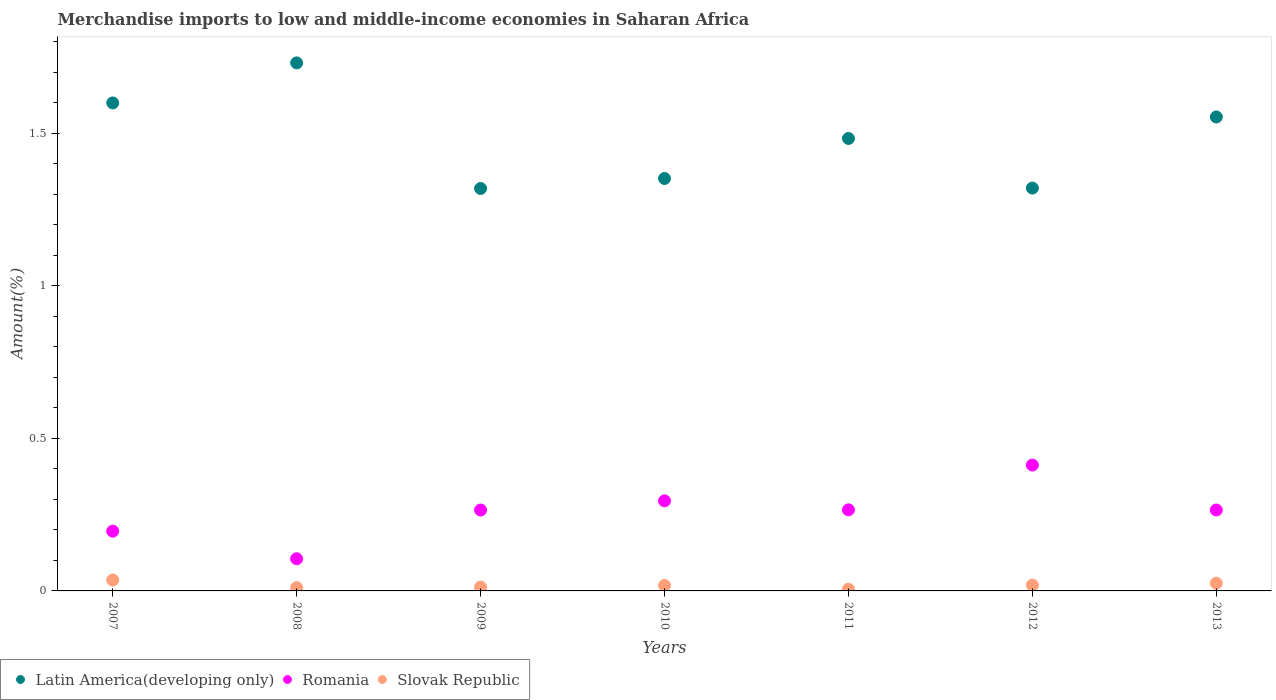How many different coloured dotlines are there?
Offer a very short reply. 3. What is the percentage of amount earned from merchandise imports in Slovak Republic in 2011?
Provide a succinct answer. 0.01. Across all years, what is the maximum percentage of amount earned from merchandise imports in Romania?
Give a very brief answer. 0.41. Across all years, what is the minimum percentage of amount earned from merchandise imports in Latin America(developing only)?
Offer a terse response. 1.32. In which year was the percentage of amount earned from merchandise imports in Latin America(developing only) minimum?
Your response must be concise. 2009. What is the total percentage of amount earned from merchandise imports in Romania in the graph?
Your answer should be compact. 1.81. What is the difference between the percentage of amount earned from merchandise imports in Romania in 2011 and that in 2013?
Provide a short and direct response. 0. What is the difference between the percentage of amount earned from merchandise imports in Latin America(developing only) in 2007 and the percentage of amount earned from merchandise imports in Slovak Republic in 2012?
Ensure brevity in your answer.  1.58. What is the average percentage of amount earned from merchandise imports in Latin America(developing only) per year?
Keep it short and to the point. 1.48. In the year 2013, what is the difference between the percentage of amount earned from merchandise imports in Romania and percentage of amount earned from merchandise imports in Latin America(developing only)?
Your answer should be compact. -1.29. In how many years, is the percentage of amount earned from merchandise imports in Slovak Republic greater than 1 %?
Keep it short and to the point. 0. What is the ratio of the percentage of amount earned from merchandise imports in Slovak Republic in 2011 to that in 2013?
Offer a terse response. 0.23. Is the difference between the percentage of amount earned from merchandise imports in Romania in 2008 and 2013 greater than the difference between the percentage of amount earned from merchandise imports in Latin America(developing only) in 2008 and 2013?
Give a very brief answer. No. What is the difference between the highest and the second highest percentage of amount earned from merchandise imports in Romania?
Provide a short and direct response. 0.12. What is the difference between the highest and the lowest percentage of amount earned from merchandise imports in Slovak Republic?
Ensure brevity in your answer.  0.03. In how many years, is the percentage of amount earned from merchandise imports in Romania greater than the average percentage of amount earned from merchandise imports in Romania taken over all years?
Ensure brevity in your answer.  5. Is the sum of the percentage of amount earned from merchandise imports in Latin America(developing only) in 2010 and 2012 greater than the maximum percentage of amount earned from merchandise imports in Romania across all years?
Make the answer very short. Yes. How many years are there in the graph?
Make the answer very short. 7. What is the difference between two consecutive major ticks on the Y-axis?
Make the answer very short. 0.5. Where does the legend appear in the graph?
Your answer should be very brief. Bottom left. How many legend labels are there?
Your response must be concise. 3. What is the title of the graph?
Ensure brevity in your answer.  Merchandise imports to low and middle-income economies in Saharan Africa. What is the label or title of the X-axis?
Offer a very short reply. Years. What is the label or title of the Y-axis?
Provide a succinct answer. Amount(%). What is the Amount(%) of Latin America(developing only) in 2007?
Offer a very short reply. 1.6. What is the Amount(%) of Romania in 2007?
Keep it short and to the point. 0.2. What is the Amount(%) of Slovak Republic in 2007?
Ensure brevity in your answer.  0.04. What is the Amount(%) of Latin America(developing only) in 2008?
Give a very brief answer. 1.73. What is the Amount(%) of Romania in 2008?
Provide a short and direct response. 0.11. What is the Amount(%) of Slovak Republic in 2008?
Make the answer very short. 0.01. What is the Amount(%) of Latin America(developing only) in 2009?
Provide a succinct answer. 1.32. What is the Amount(%) of Romania in 2009?
Provide a short and direct response. 0.27. What is the Amount(%) of Slovak Republic in 2009?
Keep it short and to the point. 0.01. What is the Amount(%) of Latin America(developing only) in 2010?
Offer a terse response. 1.35. What is the Amount(%) in Romania in 2010?
Your answer should be compact. 0.3. What is the Amount(%) in Slovak Republic in 2010?
Give a very brief answer. 0.02. What is the Amount(%) of Latin America(developing only) in 2011?
Provide a short and direct response. 1.48. What is the Amount(%) in Romania in 2011?
Your answer should be very brief. 0.27. What is the Amount(%) in Slovak Republic in 2011?
Provide a short and direct response. 0.01. What is the Amount(%) of Latin America(developing only) in 2012?
Keep it short and to the point. 1.32. What is the Amount(%) of Romania in 2012?
Your answer should be very brief. 0.41. What is the Amount(%) of Slovak Republic in 2012?
Ensure brevity in your answer.  0.02. What is the Amount(%) in Latin America(developing only) in 2013?
Offer a terse response. 1.55. What is the Amount(%) of Romania in 2013?
Keep it short and to the point. 0.27. What is the Amount(%) of Slovak Republic in 2013?
Give a very brief answer. 0.03. Across all years, what is the maximum Amount(%) in Latin America(developing only)?
Keep it short and to the point. 1.73. Across all years, what is the maximum Amount(%) of Romania?
Your answer should be compact. 0.41. Across all years, what is the maximum Amount(%) in Slovak Republic?
Your answer should be compact. 0.04. Across all years, what is the minimum Amount(%) of Latin America(developing only)?
Give a very brief answer. 1.32. Across all years, what is the minimum Amount(%) of Romania?
Your response must be concise. 0.11. Across all years, what is the minimum Amount(%) of Slovak Republic?
Provide a succinct answer. 0.01. What is the total Amount(%) in Latin America(developing only) in the graph?
Your answer should be compact. 10.36. What is the total Amount(%) of Romania in the graph?
Offer a terse response. 1.81. What is the total Amount(%) of Slovak Republic in the graph?
Your answer should be compact. 0.13. What is the difference between the Amount(%) of Latin America(developing only) in 2007 and that in 2008?
Keep it short and to the point. -0.13. What is the difference between the Amount(%) of Romania in 2007 and that in 2008?
Keep it short and to the point. 0.09. What is the difference between the Amount(%) of Slovak Republic in 2007 and that in 2008?
Offer a terse response. 0.02. What is the difference between the Amount(%) in Latin America(developing only) in 2007 and that in 2009?
Your answer should be compact. 0.28. What is the difference between the Amount(%) of Romania in 2007 and that in 2009?
Ensure brevity in your answer.  -0.07. What is the difference between the Amount(%) of Slovak Republic in 2007 and that in 2009?
Your response must be concise. 0.02. What is the difference between the Amount(%) of Latin America(developing only) in 2007 and that in 2010?
Your response must be concise. 0.25. What is the difference between the Amount(%) in Romania in 2007 and that in 2010?
Provide a succinct answer. -0.1. What is the difference between the Amount(%) of Slovak Republic in 2007 and that in 2010?
Your answer should be compact. 0.02. What is the difference between the Amount(%) of Latin America(developing only) in 2007 and that in 2011?
Ensure brevity in your answer.  0.12. What is the difference between the Amount(%) of Romania in 2007 and that in 2011?
Provide a short and direct response. -0.07. What is the difference between the Amount(%) in Slovak Republic in 2007 and that in 2011?
Your answer should be very brief. 0.03. What is the difference between the Amount(%) in Latin America(developing only) in 2007 and that in 2012?
Your answer should be compact. 0.28. What is the difference between the Amount(%) in Romania in 2007 and that in 2012?
Your response must be concise. -0.22. What is the difference between the Amount(%) in Slovak Republic in 2007 and that in 2012?
Ensure brevity in your answer.  0.02. What is the difference between the Amount(%) of Latin America(developing only) in 2007 and that in 2013?
Offer a very short reply. 0.05. What is the difference between the Amount(%) in Romania in 2007 and that in 2013?
Ensure brevity in your answer.  -0.07. What is the difference between the Amount(%) of Slovak Republic in 2007 and that in 2013?
Provide a short and direct response. 0.01. What is the difference between the Amount(%) in Latin America(developing only) in 2008 and that in 2009?
Your answer should be compact. 0.41. What is the difference between the Amount(%) of Romania in 2008 and that in 2009?
Ensure brevity in your answer.  -0.16. What is the difference between the Amount(%) of Slovak Republic in 2008 and that in 2009?
Give a very brief answer. -0. What is the difference between the Amount(%) of Latin America(developing only) in 2008 and that in 2010?
Your answer should be compact. 0.38. What is the difference between the Amount(%) in Romania in 2008 and that in 2010?
Keep it short and to the point. -0.19. What is the difference between the Amount(%) of Slovak Republic in 2008 and that in 2010?
Your response must be concise. -0.01. What is the difference between the Amount(%) in Latin America(developing only) in 2008 and that in 2011?
Your response must be concise. 0.25. What is the difference between the Amount(%) of Romania in 2008 and that in 2011?
Your response must be concise. -0.16. What is the difference between the Amount(%) in Slovak Republic in 2008 and that in 2011?
Offer a very short reply. 0.01. What is the difference between the Amount(%) of Latin America(developing only) in 2008 and that in 2012?
Provide a short and direct response. 0.41. What is the difference between the Amount(%) of Romania in 2008 and that in 2012?
Your answer should be compact. -0.31. What is the difference between the Amount(%) in Slovak Republic in 2008 and that in 2012?
Provide a short and direct response. -0.01. What is the difference between the Amount(%) of Latin America(developing only) in 2008 and that in 2013?
Your answer should be very brief. 0.18. What is the difference between the Amount(%) of Romania in 2008 and that in 2013?
Your answer should be very brief. -0.16. What is the difference between the Amount(%) of Slovak Republic in 2008 and that in 2013?
Your answer should be very brief. -0.01. What is the difference between the Amount(%) in Latin America(developing only) in 2009 and that in 2010?
Offer a terse response. -0.03. What is the difference between the Amount(%) in Romania in 2009 and that in 2010?
Your answer should be very brief. -0.03. What is the difference between the Amount(%) in Slovak Republic in 2009 and that in 2010?
Make the answer very short. -0.01. What is the difference between the Amount(%) in Latin America(developing only) in 2009 and that in 2011?
Provide a succinct answer. -0.16. What is the difference between the Amount(%) in Romania in 2009 and that in 2011?
Your answer should be very brief. -0. What is the difference between the Amount(%) of Slovak Republic in 2009 and that in 2011?
Keep it short and to the point. 0.01. What is the difference between the Amount(%) in Latin America(developing only) in 2009 and that in 2012?
Provide a short and direct response. -0. What is the difference between the Amount(%) in Romania in 2009 and that in 2012?
Make the answer very short. -0.15. What is the difference between the Amount(%) of Slovak Republic in 2009 and that in 2012?
Ensure brevity in your answer.  -0.01. What is the difference between the Amount(%) in Latin America(developing only) in 2009 and that in 2013?
Ensure brevity in your answer.  -0.23. What is the difference between the Amount(%) in Romania in 2009 and that in 2013?
Your answer should be very brief. -0. What is the difference between the Amount(%) of Slovak Republic in 2009 and that in 2013?
Give a very brief answer. -0.01. What is the difference between the Amount(%) in Latin America(developing only) in 2010 and that in 2011?
Provide a succinct answer. -0.13. What is the difference between the Amount(%) in Romania in 2010 and that in 2011?
Your answer should be compact. 0.03. What is the difference between the Amount(%) in Slovak Republic in 2010 and that in 2011?
Keep it short and to the point. 0.01. What is the difference between the Amount(%) in Latin America(developing only) in 2010 and that in 2012?
Provide a succinct answer. 0.03. What is the difference between the Amount(%) in Romania in 2010 and that in 2012?
Your response must be concise. -0.12. What is the difference between the Amount(%) of Slovak Republic in 2010 and that in 2012?
Make the answer very short. -0. What is the difference between the Amount(%) of Latin America(developing only) in 2010 and that in 2013?
Provide a short and direct response. -0.2. What is the difference between the Amount(%) of Romania in 2010 and that in 2013?
Your answer should be very brief. 0.03. What is the difference between the Amount(%) of Slovak Republic in 2010 and that in 2013?
Make the answer very short. -0.01. What is the difference between the Amount(%) in Latin America(developing only) in 2011 and that in 2012?
Keep it short and to the point. 0.16. What is the difference between the Amount(%) of Romania in 2011 and that in 2012?
Offer a very short reply. -0.15. What is the difference between the Amount(%) of Slovak Republic in 2011 and that in 2012?
Offer a very short reply. -0.01. What is the difference between the Amount(%) of Latin America(developing only) in 2011 and that in 2013?
Keep it short and to the point. -0.07. What is the difference between the Amount(%) of Slovak Republic in 2011 and that in 2013?
Your answer should be very brief. -0.02. What is the difference between the Amount(%) of Latin America(developing only) in 2012 and that in 2013?
Make the answer very short. -0.23. What is the difference between the Amount(%) in Romania in 2012 and that in 2013?
Your response must be concise. 0.15. What is the difference between the Amount(%) of Slovak Republic in 2012 and that in 2013?
Give a very brief answer. -0.01. What is the difference between the Amount(%) in Latin America(developing only) in 2007 and the Amount(%) in Romania in 2008?
Keep it short and to the point. 1.49. What is the difference between the Amount(%) of Latin America(developing only) in 2007 and the Amount(%) of Slovak Republic in 2008?
Keep it short and to the point. 1.59. What is the difference between the Amount(%) of Romania in 2007 and the Amount(%) of Slovak Republic in 2008?
Give a very brief answer. 0.19. What is the difference between the Amount(%) in Latin America(developing only) in 2007 and the Amount(%) in Romania in 2009?
Ensure brevity in your answer.  1.33. What is the difference between the Amount(%) of Latin America(developing only) in 2007 and the Amount(%) of Slovak Republic in 2009?
Ensure brevity in your answer.  1.59. What is the difference between the Amount(%) of Romania in 2007 and the Amount(%) of Slovak Republic in 2009?
Your response must be concise. 0.18. What is the difference between the Amount(%) of Latin America(developing only) in 2007 and the Amount(%) of Romania in 2010?
Offer a terse response. 1.3. What is the difference between the Amount(%) in Latin America(developing only) in 2007 and the Amount(%) in Slovak Republic in 2010?
Provide a succinct answer. 1.58. What is the difference between the Amount(%) in Romania in 2007 and the Amount(%) in Slovak Republic in 2010?
Offer a very short reply. 0.18. What is the difference between the Amount(%) in Latin America(developing only) in 2007 and the Amount(%) in Romania in 2011?
Your answer should be very brief. 1.33. What is the difference between the Amount(%) in Latin America(developing only) in 2007 and the Amount(%) in Slovak Republic in 2011?
Ensure brevity in your answer.  1.59. What is the difference between the Amount(%) in Romania in 2007 and the Amount(%) in Slovak Republic in 2011?
Provide a short and direct response. 0.19. What is the difference between the Amount(%) in Latin America(developing only) in 2007 and the Amount(%) in Romania in 2012?
Provide a succinct answer. 1.19. What is the difference between the Amount(%) in Latin America(developing only) in 2007 and the Amount(%) in Slovak Republic in 2012?
Give a very brief answer. 1.58. What is the difference between the Amount(%) in Romania in 2007 and the Amount(%) in Slovak Republic in 2012?
Keep it short and to the point. 0.18. What is the difference between the Amount(%) in Latin America(developing only) in 2007 and the Amount(%) in Romania in 2013?
Keep it short and to the point. 1.33. What is the difference between the Amount(%) of Latin America(developing only) in 2007 and the Amount(%) of Slovak Republic in 2013?
Keep it short and to the point. 1.57. What is the difference between the Amount(%) in Romania in 2007 and the Amount(%) in Slovak Republic in 2013?
Provide a short and direct response. 0.17. What is the difference between the Amount(%) of Latin America(developing only) in 2008 and the Amount(%) of Romania in 2009?
Keep it short and to the point. 1.47. What is the difference between the Amount(%) in Latin America(developing only) in 2008 and the Amount(%) in Slovak Republic in 2009?
Your response must be concise. 1.72. What is the difference between the Amount(%) in Romania in 2008 and the Amount(%) in Slovak Republic in 2009?
Your response must be concise. 0.09. What is the difference between the Amount(%) in Latin America(developing only) in 2008 and the Amount(%) in Romania in 2010?
Your answer should be compact. 1.44. What is the difference between the Amount(%) in Latin America(developing only) in 2008 and the Amount(%) in Slovak Republic in 2010?
Make the answer very short. 1.71. What is the difference between the Amount(%) in Romania in 2008 and the Amount(%) in Slovak Republic in 2010?
Give a very brief answer. 0.09. What is the difference between the Amount(%) of Latin America(developing only) in 2008 and the Amount(%) of Romania in 2011?
Your answer should be very brief. 1.47. What is the difference between the Amount(%) of Latin America(developing only) in 2008 and the Amount(%) of Slovak Republic in 2011?
Offer a terse response. 1.73. What is the difference between the Amount(%) of Romania in 2008 and the Amount(%) of Slovak Republic in 2011?
Give a very brief answer. 0.1. What is the difference between the Amount(%) of Latin America(developing only) in 2008 and the Amount(%) of Romania in 2012?
Give a very brief answer. 1.32. What is the difference between the Amount(%) of Latin America(developing only) in 2008 and the Amount(%) of Slovak Republic in 2012?
Offer a very short reply. 1.71. What is the difference between the Amount(%) of Romania in 2008 and the Amount(%) of Slovak Republic in 2012?
Provide a short and direct response. 0.09. What is the difference between the Amount(%) in Latin America(developing only) in 2008 and the Amount(%) in Romania in 2013?
Your answer should be compact. 1.47. What is the difference between the Amount(%) of Latin America(developing only) in 2008 and the Amount(%) of Slovak Republic in 2013?
Keep it short and to the point. 1.71. What is the difference between the Amount(%) in Romania in 2008 and the Amount(%) in Slovak Republic in 2013?
Make the answer very short. 0.08. What is the difference between the Amount(%) of Latin America(developing only) in 2009 and the Amount(%) of Romania in 2010?
Provide a succinct answer. 1.02. What is the difference between the Amount(%) in Latin America(developing only) in 2009 and the Amount(%) in Slovak Republic in 2010?
Ensure brevity in your answer.  1.3. What is the difference between the Amount(%) of Romania in 2009 and the Amount(%) of Slovak Republic in 2010?
Make the answer very short. 0.25. What is the difference between the Amount(%) in Latin America(developing only) in 2009 and the Amount(%) in Romania in 2011?
Offer a terse response. 1.05. What is the difference between the Amount(%) of Latin America(developing only) in 2009 and the Amount(%) of Slovak Republic in 2011?
Provide a short and direct response. 1.31. What is the difference between the Amount(%) in Romania in 2009 and the Amount(%) in Slovak Republic in 2011?
Your answer should be very brief. 0.26. What is the difference between the Amount(%) of Latin America(developing only) in 2009 and the Amount(%) of Romania in 2012?
Your answer should be compact. 0.91. What is the difference between the Amount(%) in Latin America(developing only) in 2009 and the Amount(%) in Slovak Republic in 2012?
Give a very brief answer. 1.3. What is the difference between the Amount(%) of Romania in 2009 and the Amount(%) of Slovak Republic in 2012?
Offer a very short reply. 0.25. What is the difference between the Amount(%) in Latin America(developing only) in 2009 and the Amount(%) in Romania in 2013?
Offer a terse response. 1.05. What is the difference between the Amount(%) in Latin America(developing only) in 2009 and the Amount(%) in Slovak Republic in 2013?
Ensure brevity in your answer.  1.29. What is the difference between the Amount(%) in Romania in 2009 and the Amount(%) in Slovak Republic in 2013?
Your answer should be compact. 0.24. What is the difference between the Amount(%) in Latin America(developing only) in 2010 and the Amount(%) in Romania in 2011?
Offer a terse response. 1.09. What is the difference between the Amount(%) of Latin America(developing only) in 2010 and the Amount(%) of Slovak Republic in 2011?
Make the answer very short. 1.35. What is the difference between the Amount(%) of Romania in 2010 and the Amount(%) of Slovak Republic in 2011?
Provide a succinct answer. 0.29. What is the difference between the Amount(%) in Latin America(developing only) in 2010 and the Amount(%) in Romania in 2012?
Offer a terse response. 0.94. What is the difference between the Amount(%) in Latin America(developing only) in 2010 and the Amount(%) in Slovak Republic in 2012?
Your response must be concise. 1.33. What is the difference between the Amount(%) in Romania in 2010 and the Amount(%) in Slovak Republic in 2012?
Give a very brief answer. 0.28. What is the difference between the Amount(%) in Latin America(developing only) in 2010 and the Amount(%) in Romania in 2013?
Give a very brief answer. 1.09. What is the difference between the Amount(%) in Latin America(developing only) in 2010 and the Amount(%) in Slovak Republic in 2013?
Keep it short and to the point. 1.33. What is the difference between the Amount(%) in Romania in 2010 and the Amount(%) in Slovak Republic in 2013?
Provide a succinct answer. 0.27. What is the difference between the Amount(%) of Latin America(developing only) in 2011 and the Amount(%) of Romania in 2012?
Keep it short and to the point. 1.07. What is the difference between the Amount(%) in Latin America(developing only) in 2011 and the Amount(%) in Slovak Republic in 2012?
Keep it short and to the point. 1.46. What is the difference between the Amount(%) in Romania in 2011 and the Amount(%) in Slovak Republic in 2012?
Give a very brief answer. 0.25. What is the difference between the Amount(%) of Latin America(developing only) in 2011 and the Amount(%) of Romania in 2013?
Make the answer very short. 1.22. What is the difference between the Amount(%) in Latin America(developing only) in 2011 and the Amount(%) in Slovak Republic in 2013?
Your response must be concise. 1.46. What is the difference between the Amount(%) in Romania in 2011 and the Amount(%) in Slovak Republic in 2013?
Provide a short and direct response. 0.24. What is the difference between the Amount(%) in Latin America(developing only) in 2012 and the Amount(%) in Romania in 2013?
Your answer should be very brief. 1.06. What is the difference between the Amount(%) in Latin America(developing only) in 2012 and the Amount(%) in Slovak Republic in 2013?
Offer a terse response. 1.3. What is the difference between the Amount(%) of Romania in 2012 and the Amount(%) of Slovak Republic in 2013?
Your answer should be compact. 0.39. What is the average Amount(%) in Latin America(developing only) per year?
Your answer should be very brief. 1.48. What is the average Amount(%) in Romania per year?
Ensure brevity in your answer.  0.26. What is the average Amount(%) of Slovak Republic per year?
Your response must be concise. 0.02. In the year 2007, what is the difference between the Amount(%) in Latin America(developing only) and Amount(%) in Romania?
Your response must be concise. 1.4. In the year 2007, what is the difference between the Amount(%) in Latin America(developing only) and Amount(%) in Slovak Republic?
Offer a terse response. 1.56. In the year 2007, what is the difference between the Amount(%) of Romania and Amount(%) of Slovak Republic?
Offer a very short reply. 0.16. In the year 2008, what is the difference between the Amount(%) of Latin America(developing only) and Amount(%) of Romania?
Offer a very short reply. 1.63. In the year 2008, what is the difference between the Amount(%) of Latin America(developing only) and Amount(%) of Slovak Republic?
Keep it short and to the point. 1.72. In the year 2008, what is the difference between the Amount(%) in Romania and Amount(%) in Slovak Republic?
Your answer should be compact. 0.09. In the year 2009, what is the difference between the Amount(%) in Latin America(developing only) and Amount(%) in Romania?
Ensure brevity in your answer.  1.05. In the year 2009, what is the difference between the Amount(%) of Latin America(developing only) and Amount(%) of Slovak Republic?
Offer a terse response. 1.31. In the year 2009, what is the difference between the Amount(%) of Romania and Amount(%) of Slovak Republic?
Provide a succinct answer. 0.25. In the year 2010, what is the difference between the Amount(%) of Latin America(developing only) and Amount(%) of Romania?
Offer a terse response. 1.06. In the year 2010, what is the difference between the Amount(%) in Latin America(developing only) and Amount(%) in Slovak Republic?
Ensure brevity in your answer.  1.33. In the year 2010, what is the difference between the Amount(%) of Romania and Amount(%) of Slovak Republic?
Keep it short and to the point. 0.28. In the year 2011, what is the difference between the Amount(%) in Latin America(developing only) and Amount(%) in Romania?
Ensure brevity in your answer.  1.22. In the year 2011, what is the difference between the Amount(%) in Latin America(developing only) and Amount(%) in Slovak Republic?
Give a very brief answer. 1.48. In the year 2011, what is the difference between the Amount(%) of Romania and Amount(%) of Slovak Republic?
Ensure brevity in your answer.  0.26. In the year 2012, what is the difference between the Amount(%) of Latin America(developing only) and Amount(%) of Romania?
Your answer should be compact. 0.91. In the year 2012, what is the difference between the Amount(%) of Latin America(developing only) and Amount(%) of Slovak Republic?
Your answer should be compact. 1.3. In the year 2012, what is the difference between the Amount(%) in Romania and Amount(%) in Slovak Republic?
Ensure brevity in your answer.  0.39. In the year 2013, what is the difference between the Amount(%) of Latin America(developing only) and Amount(%) of Romania?
Keep it short and to the point. 1.29. In the year 2013, what is the difference between the Amount(%) in Latin America(developing only) and Amount(%) in Slovak Republic?
Provide a short and direct response. 1.53. In the year 2013, what is the difference between the Amount(%) of Romania and Amount(%) of Slovak Republic?
Offer a very short reply. 0.24. What is the ratio of the Amount(%) of Latin America(developing only) in 2007 to that in 2008?
Make the answer very short. 0.92. What is the ratio of the Amount(%) of Romania in 2007 to that in 2008?
Give a very brief answer. 1.86. What is the ratio of the Amount(%) of Slovak Republic in 2007 to that in 2008?
Make the answer very short. 3.28. What is the ratio of the Amount(%) of Latin America(developing only) in 2007 to that in 2009?
Make the answer very short. 1.21. What is the ratio of the Amount(%) of Romania in 2007 to that in 2009?
Your answer should be very brief. 0.74. What is the ratio of the Amount(%) in Slovak Republic in 2007 to that in 2009?
Your answer should be compact. 2.85. What is the ratio of the Amount(%) in Latin America(developing only) in 2007 to that in 2010?
Your answer should be compact. 1.18. What is the ratio of the Amount(%) of Romania in 2007 to that in 2010?
Your response must be concise. 0.66. What is the ratio of the Amount(%) in Slovak Republic in 2007 to that in 2010?
Provide a succinct answer. 1.99. What is the ratio of the Amount(%) in Latin America(developing only) in 2007 to that in 2011?
Provide a short and direct response. 1.08. What is the ratio of the Amount(%) of Romania in 2007 to that in 2011?
Offer a terse response. 0.74. What is the ratio of the Amount(%) of Slovak Republic in 2007 to that in 2011?
Give a very brief answer. 6.27. What is the ratio of the Amount(%) in Latin America(developing only) in 2007 to that in 2012?
Your response must be concise. 1.21. What is the ratio of the Amount(%) in Romania in 2007 to that in 2012?
Offer a very short reply. 0.47. What is the ratio of the Amount(%) in Slovak Republic in 2007 to that in 2012?
Ensure brevity in your answer.  1.88. What is the ratio of the Amount(%) in Latin America(developing only) in 2007 to that in 2013?
Provide a short and direct response. 1.03. What is the ratio of the Amount(%) in Romania in 2007 to that in 2013?
Keep it short and to the point. 0.74. What is the ratio of the Amount(%) in Slovak Republic in 2007 to that in 2013?
Offer a very short reply. 1.41. What is the ratio of the Amount(%) in Latin America(developing only) in 2008 to that in 2009?
Provide a short and direct response. 1.31. What is the ratio of the Amount(%) in Romania in 2008 to that in 2009?
Your answer should be compact. 0.4. What is the ratio of the Amount(%) in Slovak Republic in 2008 to that in 2009?
Provide a succinct answer. 0.87. What is the ratio of the Amount(%) of Latin America(developing only) in 2008 to that in 2010?
Provide a short and direct response. 1.28. What is the ratio of the Amount(%) in Romania in 2008 to that in 2010?
Your answer should be very brief. 0.36. What is the ratio of the Amount(%) of Slovak Republic in 2008 to that in 2010?
Give a very brief answer. 0.61. What is the ratio of the Amount(%) of Latin America(developing only) in 2008 to that in 2011?
Your answer should be very brief. 1.17. What is the ratio of the Amount(%) in Romania in 2008 to that in 2011?
Ensure brevity in your answer.  0.4. What is the ratio of the Amount(%) in Slovak Republic in 2008 to that in 2011?
Provide a short and direct response. 1.91. What is the ratio of the Amount(%) of Latin America(developing only) in 2008 to that in 2012?
Keep it short and to the point. 1.31. What is the ratio of the Amount(%) in Romania in 2008 to that in 2012?
Make the answer very short. 0.26. What is the ratio of the Amount(%) of Slovak Republic in 2008 to that in 2012?
Provide a succinct answer. 0.57. What is the ratio of the Amount(%) in Latin America(developing only) in 2008 to that in 2013?
Offer a terse response. 1.11. What is the ratio of the Amount(%) in Romania in 2008 to that in 2013?
Make the answer very short. 0.4. What is the ratio of the Amount(%) in Slovak Republic in 2008 to that in 2013?
Give a very brief answer. 0.43. What is the ratio of the Amount(%) in Latin America(developing only) in 2009 to that in 2010?
Your answer should be compact. 0.98. What is the ratio of the Amount(%) in Romania in 2009 to that in 2010?
Your answer should be compact. 0.9. What is the ratio of the Amount(%) of Slovak Republic in 2009 to that in 2010?
Ensure brevity in your answer.  0.7. What is the ratio of the Amount(%) in Latin America(developing only) in 2009 to that in 2011?
Offer a very short reply. 0.89. What is the ratio of the Amount(%) in Slovak Republic in 2009 to that in 2011?
Offer a very short reply. 2.2. What is the ratio of the Amount(%) in Romania in 2009 to that in 2012?
Your answer should be compact. 0.64. What is the ratio of the Amount(%) in Slovak Republic in 2009 to that in 2012?
Provide a short and direct response. 0.66. What is the ratio of the Amount(%) of Latin America(developing only) in 2009 to that in 2013?
Offer a very short reply. 0.85. What is the ratio of the Amount(%) in Slovak Republic in 2009 to that in 2013?
Your answer should be very brief. 0.5. What is the ratio of the Amount(%) in Latin America(developing only) in 2010 to that in 2011?
Offer a very short reply. 0.91. What is the ratio of the Amount(%) in Romania in 2010 to that in 2011?
Your answer should be compact. 1.11. What is the ratio of the Amount(%) in Slovak Republic in 2010 to that in 2011?
Give a very brief answer. 3.15. What is the ratio of the Amount(%) of Latin America(developing only) in 2010 to that in 2012?
Offer a terse response. 1.02. What is the ratio of the Amount(%) in Romania in 2010 to that in 2012?
Give a very brief answer. 0.72. What is the ratio of the Amount(%) in Slovak Republic in 2010 to that in 2012?
Give a very brief answer. 0.95. What is the ratio of the Amount(%) in Latin America(developing only) in 2010 to that in 2013?
Ensure brevity in your answer.  0.87. What is the ratio of the Amount(%) in Romania in 2010 to that in 2013?
Provide a short and direct response. 1.11. What is the ratio of the Amount(%) of Slovak Republic in 2010 to that in 2013?
Your answer should be compact. 0.71. What is the ratio of the Amount(%) in Latin America(developing only) in 2011 to that in 2012?
Give a very brief answer. 1.12. What is the ratio of the Amount(%) in Romania in 2011 to that in 2012?
Offer a terse response. 0.64. What is the ratio of the Amount(%) of Slovak Republic in 2011 to that in 2012?
Provide a succinct answer. 0.3. What is the ratio of the Amount(%) of Latin America(developing only) in 2011 to that in 2013?
Keep it short and to the point. 0.95. What is the ratio of the Amount(%) in Slovak Republic in 2011 to that in 2013?
Your response must be concise. 0.23. What is the ratio of the Amount(%) in Latin America(developing only) in 2012 to that in 2013?
Make the answer very short. 0.85. What is the ratio of the Amount(%) of Romania in 2012 to that in 2013?
Give a very brief answer. 1.56. What is the ratio of the Amount(%) in Slovak Republic in 2012 to that in 2013?
Provide a short and direct response. 0.75. What is the difference between the highest and the second highest Amount(%) of Latin America(developing only)?
Your answer should be very brief. 0.13. What is the difference between the highest and the second highest Amount(%) in Romania?
Give a very brief answer. 0.12. What is the difference between the highest and the second highest Amount(%) of Slovak Republic?
Give a very brief answer. 0.01. What is the difference between the highest and the lowest Amount(%) in Latin America(developing only)?
Your answer should be very brief. 0.41. What is the difference between the highest and the lowest Amount(%) in Romania?
Offer a very short reply. 0.31. What is the difference between the highest and the lowest Amount(%) in Slovak Republic?
Keep it short and to the point. 0.03. 